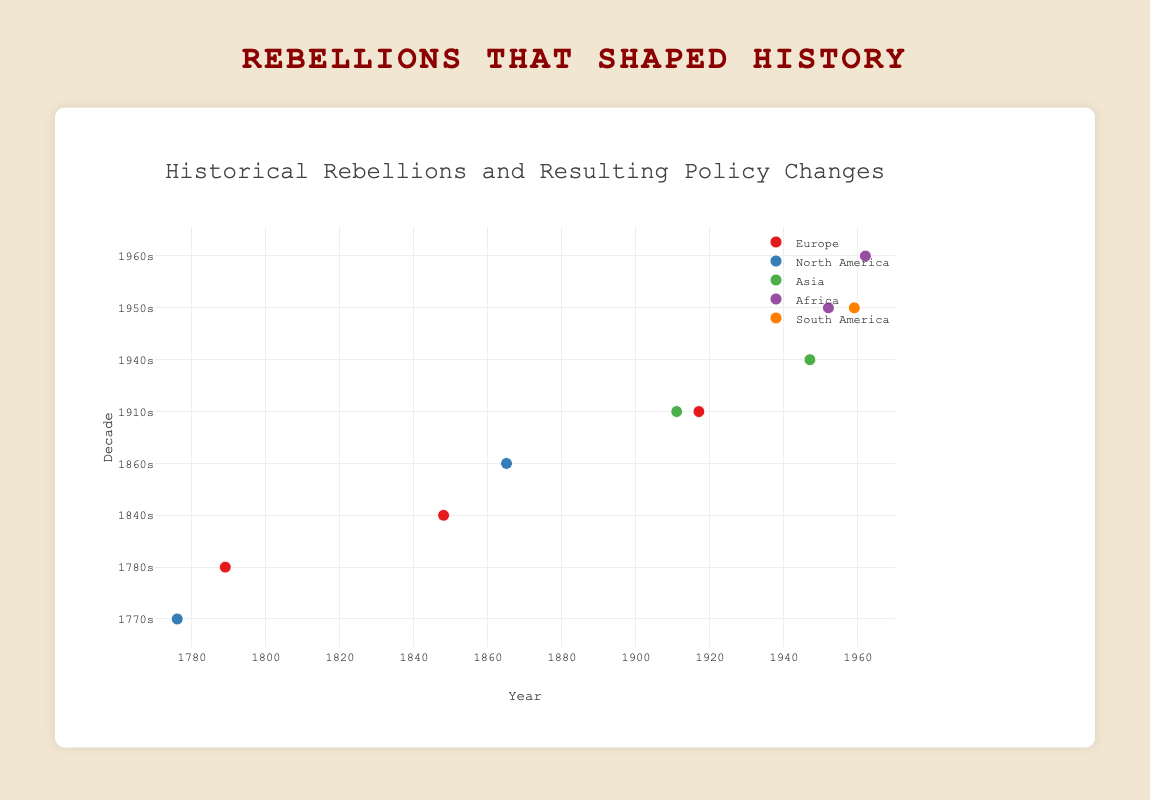What is the title of the plot? The title of the plot is displayed at the top and reads "Historical Rebellions and Resulting Policy Changes".
Answer: Historical Rebellions and Resulting Policy Changes Which continent has the most data points on the plot? By visually counting the data points for each continent, Europe has the most with three data points.
Answer: Europe What rebellion occurred in the 1940s in Asia? The data point in the 1940s for Asia is labeled as "Indian Independence Movement" with the policy change "End of British Colonial Rule".
Answer: Indian Independence Movement During which decade did the most rebellions occur according to the plot? The decade with the most data points is the 1910s, with two rebellions noted for that period.
Answer: 1910s Which rebellion resulted in the abolishment of slavery? By examining the text labels, the "American Civil War" resulted in the "Abolishment of Slavery" and is marked in the 1860s in North America.
Answer: American Civil War How many rebellions led to the end of colonial rule? By identifying the data points with policy changes mentioning the end of colonial rule, the Indian Independence Movement, Mau Mau Uprising, and Algerian War of Independence led to the end of colonial rule, totaling three rebellions.
Answer: 3 Which continent's rebellion in the 1950s paved the way for independence but didn't result in immediate independence? In the 1950s, Africa has the Mau Mau Uprising, which paved way for Kenyan Independence rather than resulting in immediate independence.
Answer: Africa Compare the years of the Xinhai Revolution and the Russian Revolution. Which happened first? The Xinhai Revolution happened in 1911, and the Russian Revolution occurred in 1917. Therefore, the Xinhai Revolution happened first.
Answer: Xinhai Revolution Which rebellion in South America is represented on the plot? In the South American section, the Cuban Revolution of the 1950s is represented, resulting in the overthrow of Batista's regime.
Answer: Cuban Revolution What is the average year of all rebellions in Europe listed on the plot? The years for Europe's rebellions are 1789 (French Revolution), 1917 (Russian Revolution), and 1848 (Springtime of Nations). The average year calculation is (1789 + 1917 + 1848) / 3 = 1851.33.
Answer: 1851.33 